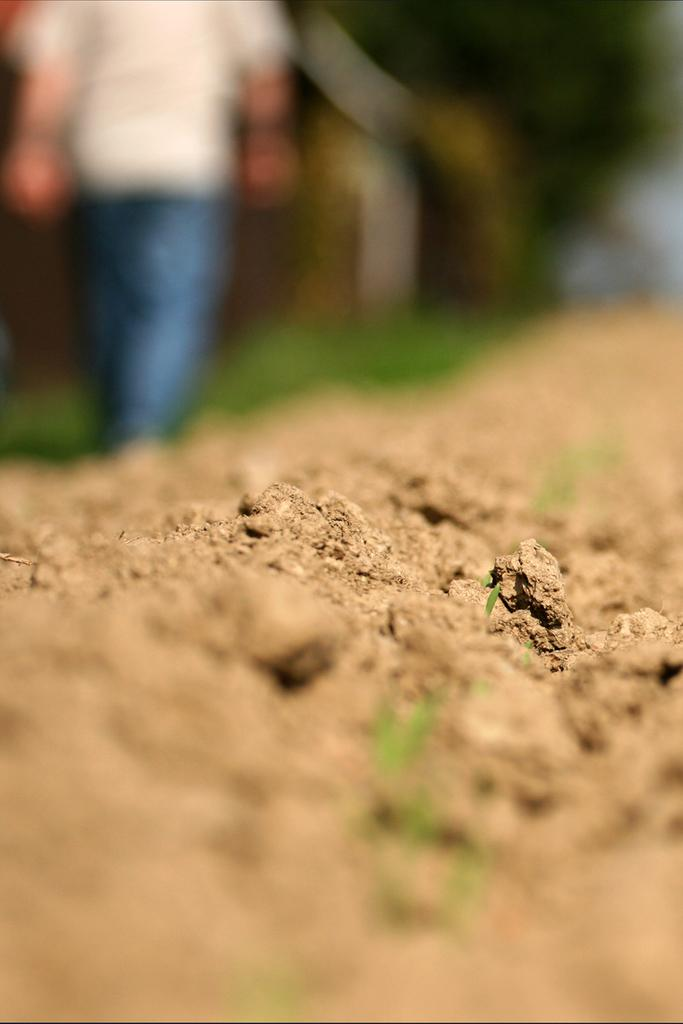What type of terrain is visible in the image? There is sand in the image. Can you describe the background of the image? The background of the image is blurred. What type of mine is present in the image? There is no mine present in the image; it only features sand and a blurred background. Can you see a donkey in the image? There is no donkey present in the image. 